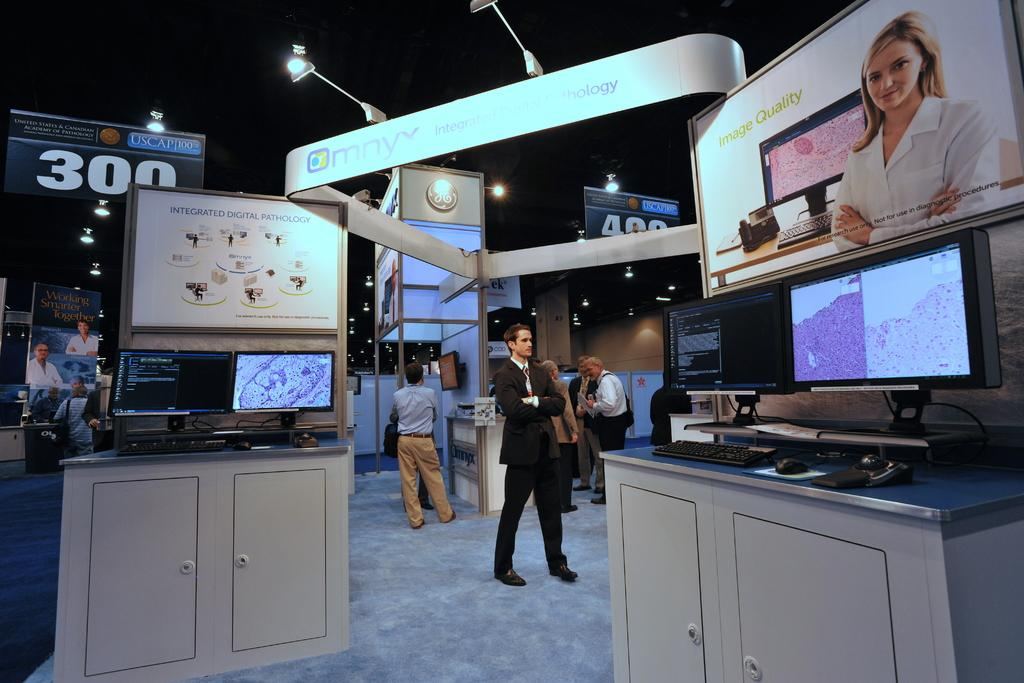Provide a one-sentence caption for the provided image. A banner at an event advertises "integrated digital pathology.". 